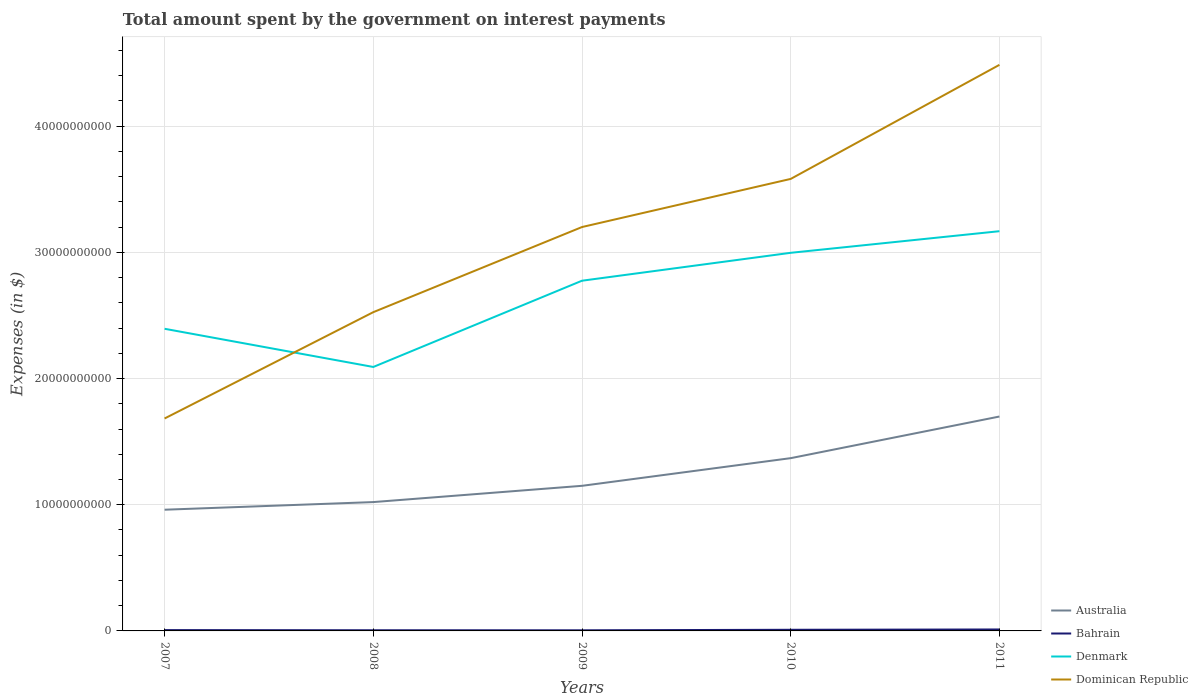Does the line corresponding to Australia intersect with the line corresponding to Dominican Republic?
Your answer should be very brief. No. Across all years, what is the maximum amount spent on interest payments by the government in Dominican Republic?
Offer a very short reply. 1.68e+1. In which year was the amount spent on interest payments by the government in Dominican Republic maximum?
Provide a succinct answer. 2007. What is the total amount spent on interest payments by the government in Bahrain in the graph?
Keep it short and to the point. 1.58e+07. What is the difference between the highest and the second highest amount spent on interest payments by the government in Australia?
Ensure brevity in your answer.  7.38e+09. What is the difference between the highest and the lowest amount spent on interest payments by the government in Denmark?
Ensure brevity in your answer.  3. Does the graph contain grids?
Provide a succinct answer. Yes. Where does the legend appear in the graph?
Give a very brief answer. Bottom right. How many legend labels are there?
Provide a short and direct response. 4. How are the legend labels stacked?
Keep it short and to the point. Vertical. What is the title of the graph?
Your answer should be compact. Total amount spent by the government on interest payments. Does "Lebanon" appear as one of the legend labels in the graph?
Your answer should be very brief. No. What is the label or title of the X-axis?
Keep it short and to the point. Years. What is the label or title of the Y-axis?
Your response must be concise. Expenses (in $). What is the Expenses (in $) in Australia in 2007?
Your response must be concise. 9.60e+09. What is the Expenses (in $) of Bahrain in 2007?
Your response must be concise. 6.59e+07. What is the Expenses (in $) in Denmark in 2007?
Give a very brief answer. 2.39e+1. What is the Expenses (in $) in Dominican Republic in 2007?
Your answer should be compact. 1.68e+1. What is the Expenses (in $) in Australia in 2008?
Provide a succinct answer. 1.02e+1. What is the Expenses (in $) in Bahrain in 2008?
Provide a succinct answer. 5.36e+07. What is the Expenses (in $) in Denmark in 2008?
Make the answer very short. 2.09e+1. What is the Expenses (in $) in Dominican Republic in 2008?
Ensure brevity in your answer.  2.53e+1. What is the Expenses (in $) of Australia in 2009?
Offer a terse response. 1.15e+1. What is the Expenses (in $) in Bahrain in 2009?
Give a very brief answer. 5.00e+07. What is the Expenses (in $) of Denmark in 2009?
Your response must be concise. 2.78e+1. What is the Expenses (in $) of Dominican Republic in 2009?
Offer a very short reply. 3.20e+1. What is the Expenses (in $) in Australia in 2010?
Provide a succinct answer. 1.37e+1. What is the Expenses (in $) in Bahrain in 2010?
Keep it short and to the point. 9.06e+07. What is the Expenses (in $) in Denmark in 2010?
Offer a terse response. 3.00e+1. What is the Expenses (in $) of Dominican Republic in 2010?
Your answer should be very brief. 3.58e+1. What is the Expenses (in $) in Australia in 2011?
Your answer should be very brief. 1.70e+1. What is the Expenses (in $) in Bahrain in 2011?
Your response must be concise. 1.15e+08. What is the Expenses (in $) of Denmark in 2011?
Your response must be concise. 3.17e+1. What is the Expenses (in $) in Dominican Republic in 2011?
Ensure brevity in your answer.  4.49e+1. Across all years, what is the maximum Expenses (in $) in Australia?
Make the answer very short. 1.70e+1. Across all years, what is the maximum Expenses (in $) of Bahrain?
Your response must be concise. 1.15e+08. Across all years, what is the maximum Expenses (in $) in Denmark?
Your answer should be compact. 3.17e+1. Across all years, what is the maximum Expenses (in $) in Dominican Republic?
Provide a succinct answer. 4.49e+1. Across all years, what is the minimum Expenses (in $) in Australia?
Offer a terse response. 9.60e+09. Across all years, what is the minimum Expenses (in $) in Bahrain?
Give a very brief answer. 5.00e+07. Across all years, what is the minimum Expenses (in $) of Denmark?
Keep it short and to the point. 2.09e+1. Across all years, what is the minimum Expenses (in $) in Dominican Republic?
Offer a very short reply. 1.68e+1. What is the total Expenses (in $) in Australia in the graph?
Provide a succinct answer. 6.20e+1. What is the total Expenses (in $) of Bahrain in the graph?
Your response must be concise. 3.75e+08. What is the total Expenses (in $) in Denmark in the graph?
Provide a short and direct response. 1.34e+11. What is the total Expenses (in $) in Dominican Republic in the graph?
Give a very brief answer. 1.55e+11. What is the difference between the Expenses (in $) of Australia in 2007 and that in 2008?
Make the answer very short. -6.05e+08. What is the difference between the Expenses (in $) of Bahrain in 2007 and that in 2008?
Keep it short and to the point. 1.23e+07. What is the difference between the Expenses (in $) of Denmark in 2007 and that in 2008?
Keep it short and to the point. 3.03e+09. What is the difference between the Expenses (in $) in Dominican Republic in 2007 and that in 2008?
Provide a succinct answer. -8.43e+09. What is the difference between the Expenses (in $) of Australia in 2007 and that in 2009?
Your response must be concise. -1.89e+09. What is the difference between the Expenses (in $) of Bahrain in 2007 and that in 2009?
Your answer should be compact. 1.58e+07. What is the difference between the Expenses (in $) in Denmark in 2007 and that in 2009?
Offer a terse response. -3.81e+09. What is the difference between the Expenses (in $) in Dominican Republic in 2007 and that in 2009?
Offer a very short reply. -1.52e+1. What is the difference between the Expenses (in $) of Australia in 2007 and that in 2010?
Keep it short and to the point. -4.09e+09. What is the difference between the Expenses (in $) of Bahrain in 2007 and that in 2010?
Make the answer very short. -2.47e+07. What is the difference between the Expenses (in $) of Denmark in 2007 and that in 2010?
Make the answer very short. -6.02e+09. What is the difference between the Expenses (in $) in Dominican Republic in 2007 and that in 2010?
Provide a succinct answer. -1.90e+1. What is the difference between the Expenses (in $) in Australia in 2007 and that in 2011?
Give a very brief answer. -7.38e+09. What is the difference between the Expenses (in $) in Bahrain in 2007 and that in 2011?
Provide a short and direct response. -4.86e+07. What is the difference between the Expenses (in $) in Denmark in 2007 and that in 2011?
Your answer should be compact. -7.73e+09. What is the difference between the Expenses (in $) of Dominican Republic in 2007 and that in 2011?
Ensure brevity in your answer.  -2.80e+1. What is the difference between the Expenses (in $) of Australia in 2008 and that in 2009?
Keep it short and to the point. -1.29e+09. What is the difference between the Expenses (in $) in Bahrain in 2008 and that in 2009?
Your answer should be very brief. 3.56e+06. What is the difference between the Expenses (in $) of Denmark in 2008 and that in 2009?
Offer a terse response. -6.84e+09. What is the difference between the Expenses (in $) in Dominican Republic in 2008 and that in 2009?
Your response must be concise. -6.75e+09. What is the difference between the Expenses (in $) in Australia in 2008 and that in 2010?
Your response must be concise. -3.48e+09. What is the difference between the Expenses (in $) of Bahrain in 2008 and that in 2010?
Ensure brevity in your answer.  -3.70e+07. What is the difference between the Expenses (in $) of Denmark in 2008 and that in 2010?
Give a very brief answer. -9.05e+09. What is the difference between the Expenses (in $) in Dominican Republic in 2008 and that in 2010?
Ensure brevity in your answer.  -1.06e+1. What is the difference between the Expenses (in $) in Australia in 2008 and that in 2011?
Ensure brevity in your answer.  -6.78e+09. What is the difference between the Expenses (in $) in Bahrain in 2008 and that in 2011?
Give a very brief answer. -6.09e+07. What is the difference between the Expenses (in $) in Denmark in 2008 and that in 2011?
Provide a succinct answer. -1.08e+1. What is the difference between the Expenses (in $) in Dominican Republic in 2008 and that in 2011?
Offer a terse response. -1.96e+1. What is the difference between the Expenses (in $) of Australia in 2009 and that in 2010?
Ensure brevity in your answer.  -2.19e+09. What is the difference between the Expenses (in $) in Bahrain in 2009 and that in 2010?
Provide a succinct answer. -4.05e+07. What is the difference between the Expenses (in $) in Denmark in 2009 and that in 2010?
Keep it short and to the point. -2.21e+09. What is the difference between the Expenses (in $) of Dominican Republic in 2009 and that in 2010?
Give a very brief answer. -3.81e+09. What is the difference between the Expenses (in $) of Australia in 2009 and that in 2011?
Your answer should be very brief. -5.49e+09. What is the difference between the Expenses (in $) of Bahrain in 2009 and that in 2011?
Your answer should be very brief. -6.45e+07. What is the difference between the Expenses (in $) of Denmark in 2009 and that in 2011?
Give a very brief answer. -3.92e+09. What is the difference between the Expenses (in $) in Dominican Republic in 2009 and that in 2011?
Your response must be concise. -1.29e+1. What is the difference between the Expenses (in $) of Australia in 2010 and that in 2011?
Provide a short and direct response. -3.30e+09. What is the difference between the Expenses (in $) in Bahrain in 2010 and that in 2011?
Your answer should be very brief. -2.39e+07. What is the difference between the Expenses (in $) of Denmark in 2010 and that in 2011?
Ensure brevity in your answer.  -1.71e+09. What is the difference between the Expenses (in $) of Dominican Republic in 2010 and that in 2011?
Your response must be concise. -9.04e+09. What is the difference between the Expenses (in $) in Australia in 2007 and the Expenses (in $) in Bahrain in 2008?
Keep it short and to the point. 9.55e+09. What is the difference between the Expenses (in $) of Australia in 2007 and the Expenses (in $) of Denmark in 2008?
Offer a very short reply. -1.13e+1. What is the difference between the Expenses (in $) in Australia in 2007 and the Expenses (in $) in Dominican Republic in 2008?
Your answer should be very brief. -1.57e+1. What is the difference between the Expenses (in $) of Bahrain in 2007 and the Expenses (in $) of Denmark in 2008?
Offer a very short reply. -2.09e+1. What is the difference between the Expenses (in $) in Bahrain in 2007 and the Expenses (in $) in Dominican Republic in 2008?
Provide a succinct answer. -2.52e+1. What is the difference between the Expenses (in $) in Denmark in 2007 and the Expenses (in $) in Dominican Republic in 2008?
Give a very brief answer. -1.32e+09. What is the difference between the Expenses (in $) of Australia in 2007 and the Expenses (in $) of Bahrain in 2009?
Ensure brevity in your answer.  9.55e+09. What is the difference between the Expenses (in $) of Australia in 2007 and the Expenses (in $) of Denmark in 2009?
Your answer should be compact. -1.81e+1. What is the difference between the Expenses (in $) of Australia in 2007 and the Expenses (in $) of Dominican Republic in 2009?
Your answer should be very brief. -2.24e+1. What is the difference between the Expenses (in $) in Bahrain in 2007 and the Expenses (in $) in Denmark in 2009?
Make the answer very short. -2.77e+1. What is the difference between the Expenses (in $) in Bahrain in 2007 and the Expenses (in $) in Dominican Republic in 2009?
Your answer should be very brief. -3.19e+1. What is the difference between the Expenses (in $) of Denmark in 2007 and the Expenses (in $) of Dominican Republic in 2009?
Keep it short and to the point. -8.06e+09. What is the difference between the Expenses (in $) in Australia in 2007 and the Expenses (in $) in Bahrain in 2010?
Your answer should be very brief. 9.51e+09. What is the difference between the Expenses (in $) of Australia in 2007 and the Expenses (in $) of Denmark in 2010?
Make the answer very short. -2.04e+1. What is the difference between the Expenses (in $) in Australia in 2007 and the Expenses (in $) in Dominican Republic in 2010?
Keep it short and to the point. -2.62e+1. What is the difference between the Expenses (in $) of Bahrain in 2007 and the Expenses (in $) of Denmark in 2010?
Your answer should be compact. -2.99e+1. What is the difference between the Expenses (in $) of Bahrain in 2007 and the Expenses (in $) of Dominican Republic in 2010?
Offer a very short reply. -3.58e+1. What is the difference between the Expenses (in $) in Denmark in 2007 and the Expenses (in $) in Dominican Republic in 2010?
Make the answer very short. -1.19e+1. What is the difference between the Expenses (in $) in Australia in 2007 and the Expenses (in $) in Bahrain in 2011?
Your answer should be very brief. 9.49e+09. What is the difference between the Expenses (in $) in Australia in 2007 and the Expenses (in $) in Denmark in 2011?
Provide a short and direct response. -2.21e+1. What is the difference between the Expenses (in $) in Australia in 2007 and the Expenses (in $) in Dominican Republic in 2011?
Your response must be concise. -3.53e+1. What is the difference between the Expenses (in $) of Bahrain in 2007 and the Expenses (in $) of Denmark in 2011?
Give a very brief answer. -3.16e+1. What is the difference between the Expenses (in $) in Bahrain in 2007 and the Expenses (in $) in Dominican Republic in 2011?
Ensure brevity in your answer.  -4.48e+1. What is the difference between the Expenses (in $) of Denmark in 2007 and the Expenses (in $) of Dominican Republic in 2011?
Offer a terse response. -2.09e+1. What is the difference between the Expenses (in $) of Australia in 2008 and the Expenses (in $) of Bahrain in 2009?
Your response must be concise. 1.02e+1. What is the difference between the Expenses (in $) of Australia in 2008 and the Expenses (in $) of Denmark in 2009?
Offer a very short reply. -1.75e+1. What is the difference between the Expenses (in $) in Australia in 2008 and the Expenses (in $) in Dominican Republic in 2009?
Your answer should be very brief. -2.18e+1. What is the difference between the Expenses (in $) in Bahrain in 2008 and the Expenses (in $) in Denmark in 2009?
Your answer should be very brief. -2.77e+1. What is the difference between the Expenses (in $) of Bahrain in 2008 and the Expenses (in $) of Dominican Republic in 2009?
Provide a short and direct response. -3.20e+1. What is the difference between the Expenses (in $) in Denmark in 2008 and the Expenses (in $) in Dominican Republic in 2009?
Give a very brief answer. -1.11e+1. What is the difference between the Expenses (in $) in Australia in 2008 and the Expenses (in $) in Bahrain in 2010?
Your answer should be compact. 1.01e+1. What is the difference between the Expenses (in $) of Australia in 2008 and the Expenses (in $) of Denmark in 2010?
Your answer should be very brief. -1.98e+1. What is the difference between the Expenses (in $) in Australia in 2008 and the Expenses (in $) in Dominican Republic in 2010?
Ensure brevity in your answer.  -2.56e+1. What is the difference between the Expenses (in $) of Bahrain in 2008 and the Expenses (in $) of Denmark in 2010?
Provide a succinct answer. -2.99e+1. What is the difference between the Expenses (in $) in Bahrain in 2008 and the Expenses (in $) in Dominican Republic in 2010?
Provide a short and direct response. -3.58e+1. What is the difference between the Expenses (in $) of Denmark in 2008 and the Expenses (in $) of Dominican Republic in 2010?
Give a very brief answer. -1.49e+1. What is the difference between the Expenses (in $) in Australia in 2008 and the Expenses (in $) in Bahrain in 2011?
Your answer should be compact. 1.01e+1. What is the difference between the Expenses (in $) in Australia in 2008 and the Expenses (in $) in Denmark in 2011?
Ensure brevity in your answer.  -2.15e+1. What is the difference between the Expenses (in $) of Australia in 2008 and the Expenses (in $) of Dominican Republic in 2011?
Give a very brief answer. -3.46e+1. What is the difference between the Expenses (in $) of Bahrain in 2008 and the Expenses (in $) of Denmark in 2011?
Ensure brevity in your answer.  -3.16e+1. What is the difference between the Expenses (in $) in Bahrain in 2008 and the Expenses (in $) in Dominican Republic in 2011?
Give a very brief answer. -4.48e+1. What is the difference between the Expenses (in $) of Denmark in 2008 and the Expenses (in $) of Dominican Republic in 2011?
Give a very brief answer. -2.39e+1. What is the difference between the Expenses (in $) in Australia in 2009 and the Expenses (in $) in Bahrain in 2010?
Give a very brief answer. 1.14e+1. What is the difference between the Expenses (in $) of Australia in 2009 and the Expenses (in $) of Denmark in 2010?
Ensure brevity in your answer.  -1.85e+1. What is the difference between the Expenses (in $) of Australia in 2009 and the Expenses (in $) of Dominican Republic in 2010?
Make the answer very short. -2.43e+1. What is the difference between the Expenses (in $) in Bahrain in 2009 and the Expenses (in $) in Denmark in 2010?
Your answer should be compact. -2.99e+1. What is the difference between the Expenses (in $) in Bahrain in 2009 and the Expenses (in $) in Dominican Republic in 2010?
Your answer should be compact. -3.58e+1. What is the difference between the Expenses (in $) in Denmark in 2009 and the Expenses (in $) in Dominican Republic in 2010?
Provide a succinct answer. -8.07e+09. What is the difference between the Expenses (in $) in Australia in 2009 and the Expenses (in $) in Bahrain in 2011?
Provide a short and direct response. 1.14e+1. What is the difference between the Expenses (in $) in Australia in 2009 and the Expenses (in $) in Denmark in 2011?
Provide a short and direct response. -2.02e+1. What is the difference between the Expenses (in $) of Australia in 2009 and the Expenses (in $) of Dominican Republic in 2011?
Your answer should be very brief. -3.34e+1. What is the difference between the Expenses (in $) in Bahrain in 2009 and the Expenses (in $) in Denmark in 2011?
Your answer should be very brief. -3.16e+1. What is the difference between the Expenses (in $) of Bahrain in 2009 and the Expenses (in $) of Dominican Republic in 2011?
Offer a very short reply. -4.48e+1. What is the difference between the Expenses (in $) in Denmark in 2009 and the Expenses (in $) in Dominican Republic in 2011?
Your answer should be compact. -1.71e+1. What is the difference between the Expenses (in $) in Australia in 2010 and the Expenses (in $) in Bahrain in 2011?
Provide a short and direct response. 1.36e+1. What is the difference between the Expenses (in $) of Australia in 2010 and the Expenses (in $) of Denmark in 2011?
Make the answer very short. -1.80e+1. What is the difference between the Expenses (in $) in Australia in 2010 and the Expenses (in $) in Dominican Republic in 2011?
Offer a very short reply. -3.12e+1. What is the difference between the Expenses (in $) of Bahrain in 2010 and the Expenses (in $) of Denmark in 2011?
Your answer should be very brief. -3.16e+1. What is the difference between the Expenses (in $) in Bahrain in 2010 and the Expenses (in $) in Dominican Republic in 2011?
Give a very brief answer. -4.48e+1. What is the difference between the Expenses (in $) in Denmark in 2010 and the Expenses (in $) in Dominican Republic in 2011?
Make the answer very short. -1.49e+1. What is the average Expenses (in $) in Australia per year?
Your answer should be very brief. 1.24e+1. What is the average Expenses (in $) of Bahrain per year?
Make the answer very short. 7.49e+07. What is the average Expenses (in $) of Denmark per year?
Keep it short and to the point. 2.69e+1. What is the average Expenses (in $) in Dominican Republic per year?
Provide a short and direct response. 3.10e+1. In the year 2007, what is the difference between the Expenses (in $) of Australia and Expenses (in $) of Bahrain?
Your answer should be compact. 9.54e+09. In the year 2007, what is the difference between the Expenses (in $) of Australia and Expenses (in $) of Denmark?
Offer a very short reply. -1.43e+1. In the year 2007, what is the difference between the Expenses (in $) in Australia and Expenses (in $) in Dominican Republic?
Your answer should be very brief. -7.23e+09. In the year 2007, what is the difference between the Expenses (in $) of Bahrain and Expenses (in $) of Denmark?
Offer a terse response. -2.39e+1. In the year 2007, what is the difference between the Expenses (in $) in Bahrain and Expenses (in $) in Dominican Republic?
Keep it short and to the point. -1.68e+1. In the year 2007, what is the difference between the Expenses (in $) of Denmark and Expenses (in $) of Dominican Republic?
Make the answer very short. 7.11e+09. In the year 2008, what is the difference between the Expenses (in $) in Australia and Expenses (in $) in Bahrain?
Your response must be concise. 1.02e+1. In the year 2008, what is the difference between the Expenses (in $) of Australia and Expenses (in $) of Denmark?
Ensure brevity in your answer.  -1.07e+1. In the year 2008, what is the difference between the Expenses (in $) of Australia and Expenses (in $) of Dominican Republic?
Offer a very short reply. -1.51e+1. In the year 2008, what is the difference between the Expenses (in $) in Bahrain and Expenses (in $) in Denmark?
Your response must be concise. -2.09e+1. In the year 2008, what is the difference between the Expenses (in $) of Bahrain and Expenses (in $) of Dominican Republic?
Your answer should be compact. -2.52e+1. In the year 2008, what is the difference between the Expenses (in $) of Denmark and Expenses (in $) of Dominican Republic?
Provide a succinct answer. -4.34e+09. In the year 2009, what is the difference between the Expenses (in $) in Australia and Expenses (in $) in Bahrain?
Provide a succinct answer. 1.14e+1. In the year 2009, what is the difference between the Expenses (in $) in Australia and Expenses (in $) in Denmark?
Keep it short and to the point. -1.63e+1. In the year 2009, what is the difference between the Expenses (in $) in Australia and Expenses (in $) in Dominican Republic?
Keep it short and to the point. -2.05e+1. In the year 2009, what is the difference between the Expenses (in $) in Bahrain and Expenses (in $) in Denmark?
Provide a short and direct response. -2.77e+1. In the year 2009, what is the difference between the Expenses (in $) of Bahrain and Expenses (in $) of Dominican Republic?
Make the answer very short. -3.20e+1. In the year 2009, what is the difference between the Expenses (in $) in Denmark and Expenses (in $) in Dominican Republic?
Make the answer very short. -4.25e+09. In the year 2010, what is the difference between the Expenses (in $) in Australia and Expenses (in $) in Bahrain?
Offer a very short reply. 1.36e+1. In the year 2010, what is the difference between the Expenses (in $) of Australia and Expenses (in $) of Denmark?
Give a very brief answer. -1.63e+1. In the year 2010, what is the difference between the Expenses (in $) in Australia and Expenses (in $) in Dominican Republic?
Keep it short and to the point. -2.21e+1. In the year 2010, what is the difference between the Expenses (in $) of Bahrain and Expenses (in $) of Denmark?
Give a very brief answer. -2.99e+1. In the year 2010, what is the difference between the Expenses (in $) in Bahrain and Expenses (in $) in Dominican Republic?
Make the answer very short. -3.57e+1. In the year 2010, what is the difference between the Expenses (in $) of Denmark and Expenses (in $) of Dominican Republic?
Your answer should be compact. -5.86e+09. In the year 2011, what is the difference between the Expenses (in $) in Australia and Expenses (in $) in Bahrain?
Make the answer very short. 1.69e+1. In the year 2011, what is the difference between the Expenses (in $) in Australia and Expenses (in $) in Denmark?
Keep it short and to the point. -1.47e+1. In the year 2011, what is the difference between the Expenses (in $) in Australia and Expenses (in $) in Dominican Republic?
Your answer should be very brief. -2.79e+1. In the year 2011, what is the difference between the Expenses (in $) in Bahrain and Expenses (in $) in Denmark?
Ensure brevity in your answer.  -3.16e+1. In the year 2011, what is the difference between the Expenses (in $) in Bahrain and Expenses (in $) in Dominican Republic?
Offer a very short reply. -4.47e+1. In the year 2011, what is the difference between the Expenses (in $) in Denmark and Expenses (in $) in Dominican Republic?
Offer a very short reply. -1.32e+1. What is the ratio of the Expenses (in $) of Australia in 2007 to that in 2008?
Keep it short and to the point. 0.94. What is the ratio of the Expenses (in $) of Bahrain in 2007 to that in 2008?
Keep it short and to the point. 1.23. What is the ratio of the Expenses (in $) in Denmark in 2007 to that in 2008?
Offer a terse response. 1.14. What is the ratio of the Expenses (in $) in Dominican Republic in 2007 to that in 2008?
Give a very brief answer. 0.67. What is the ratio of the Expenses (in $) of Australia in 2007 to that in 2009?
Provide a short and direct response. 0.84. What is the ratio of the Expenses (in $) in Bahrain in 2007 to that in 2009?
Ensure brevity in your answer.  1.32. What is the ratio of the Expenses (in $) of Denmark in 2007 to that in 2009?
Provide a succinct answer. 0.86. What is the ratio of the Expenses (in $) of Dominican Republic in 2007 to that in 2009?
Provide a succinct answer. 0.53. What is the ratio of the Expenses (in $) in Australia in 2007 to that in 2010?
Provide a succinct answer. 0.7. What is the ratio of the Expenses (in $) in Bahrain in 2007 to that in 2010?
Offer a very short reply. 0.73. What is the ratio of the Expenses (in $) of Denmark in 2007 to that in 2010?
Give a very brief answer. 0.8. What is the ratio of the Expenses (in $) in Dominican Republic in 2007 to that in 2010?
Offer a very short reply. 0.47. What is the ratio of the Expenses (in $) of Australia in 2007 to that in 2011?
Ensure brevity in your answer.  0.57. What is the ratio of the Expenses (in $) in Bahrain in 2007 to that in 2011?
Offer a terse response. 0.58. What is the ratio of the Expenses (in $) in Denmark in 2007 to that in 2011?
Your answer should be very brief. 0.76. What is the ratio of the Expenses (in $) of Dominican Republic in 2007 to that in 2011?
Your answer should be compact. 0.38. What is the ratio of the Expenses (in $) of Australia in 2008 to that in 2009?
Provide a short and direct response. 0.89. What is the ratio of the Expenses (in $) in Bahrain in 2008 to that in 2009?
Keep it short and to the point. 1.07. What is the ratio of the Expenses (in $) of Denmark in 2008 to that in 2009?
Your answer should be very brief. 0.75. What is the ratio of the Expenses (in $) in Dominican Republic in 2008 to that in 2009?
Provide a short and direct response. 0.79. What is the ratio of the Expenses (in $) in Australia in 2008 to that in 2010?
Provide a short and direct response. 0.75. What is the ratio of the Expenses (in $) of Bahrain in 2008 to that in 2010?
Your answer should be very brief. 0.59. What is the ratio of the Expenses (in $) in Denmark in 2008 to that in 2010?
Offer a terse response. 0.7. What is the ratio of the Expenses (in $) of Dominican Republic in 2008 to that in 2010?
Your response must be concise. 0.71. What is the ratio of the Expenses (in $) in Australia in 2008 to that in 2011?
Your answer should be very brief. 0.6. What is the ratio of the Expenses (in $) of Bahrain in 2008 to that in 2011?
Offer a terse response. 0.47. What is the ratio of the Expenses (in $) in Denmark in 2008 to that in 2011?
Provide a short and direct response. 0.66. What is the ratio of the Expenses (in $) in Dominican Republic in 2008 to that in 2011?
Your answer should be very brief. 0.56. What is the ratio of the Expenses (in $) in Australia in 2009 to that in 2010?
Your response must be concise. 0.84. What is the ratio of the Expenses (in $) in Bahrain in 2009 to that in 2010?
Your answer should be very brief. 0.55. What is the ratio of the Expenses (in $) in Denmark in 2009 to that in 2010?
Offer a very short reply. 0.93. What is the ratio of the Expenses (in $) in Dominican Republic in 2009 to that in 2010?
Your answer should be very brief. 0.89. What is the ratio of the Expenses (in $) in Australia in 2009 to that in 2011?
Give a very brief answer. 0.68. What is the ratio of the Expenses (in $) of Bahrain in 2009 to that in 2011?
Offer a very short reply. 0.44. What is the ratio of the Expenses (in $) in Denmark in 2009 to that in 2011?
Offer a very short reply. 0.88. What is the ratio of the Expenses (in $) of Dominican Republic in 2009 to that in 2011?
Your answer should be compact. 0.71. What is the ratio of the Expenses (in $) in Australia in 2010 to that in 2011?
Your answer should be very brief. 0.81. What is the ratio of the Expenses (in $) of Bahrain in 2010 to that in 2011?
Your answer should be compact. 0.79. What is the ratio of the Expenses (in $) of Denmark in 2010 to that in 2011?
Your response must be concise. 0.95. What is the ratio of the Expenses (in $) in Dominican Republic in 2010 to that in 2011?
Offer a terse response. 0.8. What is the difference between the highest and the second highest Expenses (in $) of Australia?
Offer a very short reply. 3.30e+09. What is the difference between the highest and the second highest Expenses (in $) of Bahrain?
Ensure brevity in your answer.  2.39e+07. What is the difference between the highest and the second highest Expenses (in $) of Denmark?
Provide a short and direct response. 1.71e+09. What is the difference between the highest and the second highest Expenses (in $) of Dominican Republic?
Give a very brief answer. 9.04e+09. What is the difference between the highest and the lowest Expenses (in $) of Australia?
Your response must be concise. 7.38e+09. What is the difference between the highest and the lowest Expenses (in $) of Bahrain?
Your response must be concise. 6.45e+07. What is the difference between the highest and the lowest Expenses (in $) in Denmark?
Offer a very short reply. 1.08e+1. What is the difference between the highest and the lowest Expenses (in $) in Dominican Republic?
Make the answer very short. 2.80e+1. 